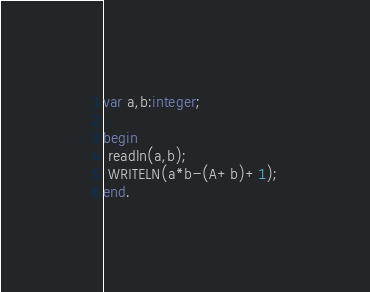<code> <loc_0><loc_0><loc_500><loc_500><_Pascal_>var a,b:integer;

begin
 readln(a,b);
 WRITELN(a*b-(A+b)+1);
end.</code> 